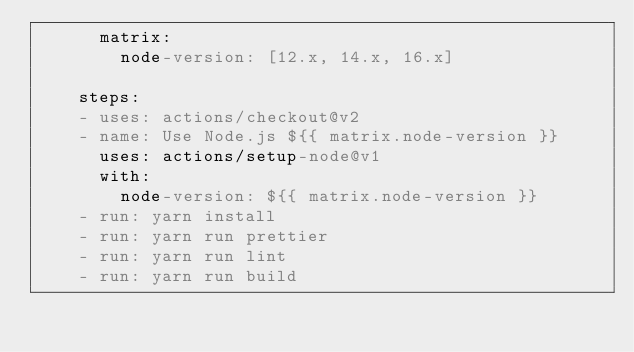Convert code to text. <code><loc_0><loc_0><loc_500><loc_500><_YAML_>      matrix:
        node-version: [12.x, 14.x, 16.x]

    steps:
    - uses: actions/checkout@v2
    - name: Use Node.js ${{ matrix.node-version }}
      uses: actions/setup-node@v1
      with:
        node-version: ${{ matrix.node-version }}
    - run: yarn install
    - run: yarn run prettier
    - run: yarn run lint
    - run: yarn run build
</code> 